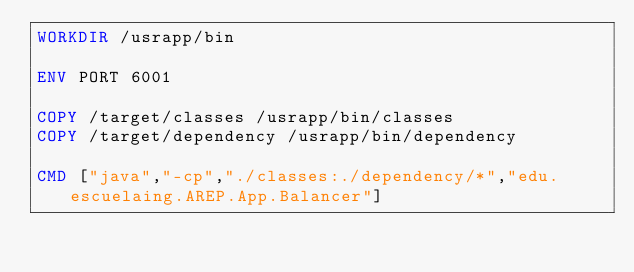<code> <loc_0><loc_0><loc_500><loc_500><_Dockerfile_>WORKDIR /usrapp/bin

ENV PORT 6001

COPY /target/classes /usrapp/bin/classes
COPY /target/dependency /usrapp/bin/dependency

CMD ["java","-cp","./classes:./dependency/*","edu.escuelaing.AREP.App.Balancer"]
</code> 